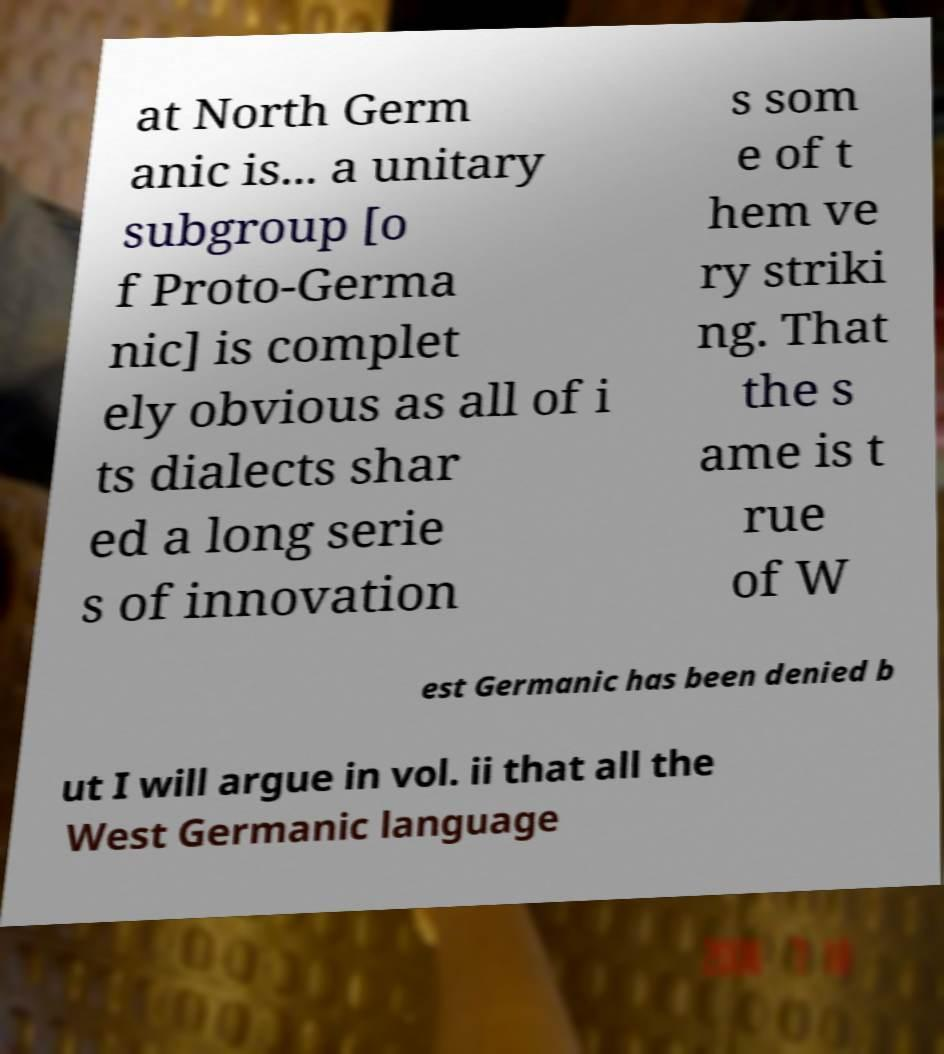Can you accurately transcribe the text from the provided image for me? at North Germ anic is... a unitary subgroup [o f Proto-Germa nic] is complet ely obvious as all of i ts dialects shar ed a long serie s of innovation s som e of t hem ve ry striki ng. That the s ame is t rue of W est Germanic has been denied b ut I will argue in vol. ii that all the West Germanic language 